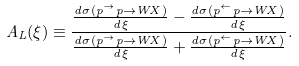Convert formula to latex. <formula><loc_0><loc_0><loc_500><loc_500>A _ { L } ( \xi ) \equiv \frac { \frac { d \sigma ( p ^ { \rightarrow } p \rightarrow W X ) } { d \xi } - \frac { d \sigma ( p ^ { \leftarrow } p \rightarrow W X ) } { d \xi } } { \frac { d \sigma ( p ^ { \rightarrow } p \rightarrow W X ) } { d \xi } + \frac { d \sigma ( p ^ { \leftarrow } p \rightarrow W X ) } { d \xi } } .</formula> 